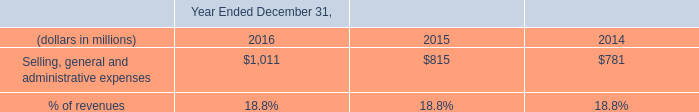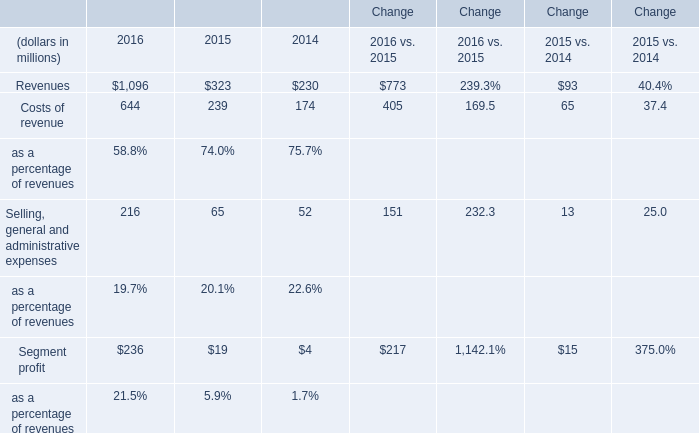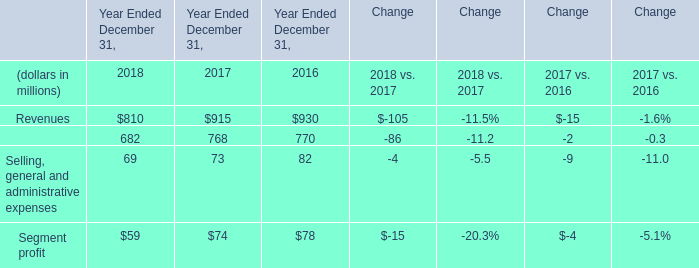What is the ratio of Costs of revenue to the Costs of revenue, exclusive of depreciationand amortization in 2016? 
Computations: (644 / 770)
Answer: 0.83636. 